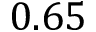<formula> <loc_0><loc_0><loc_500><loc_500>0 . 6 5</formula> 